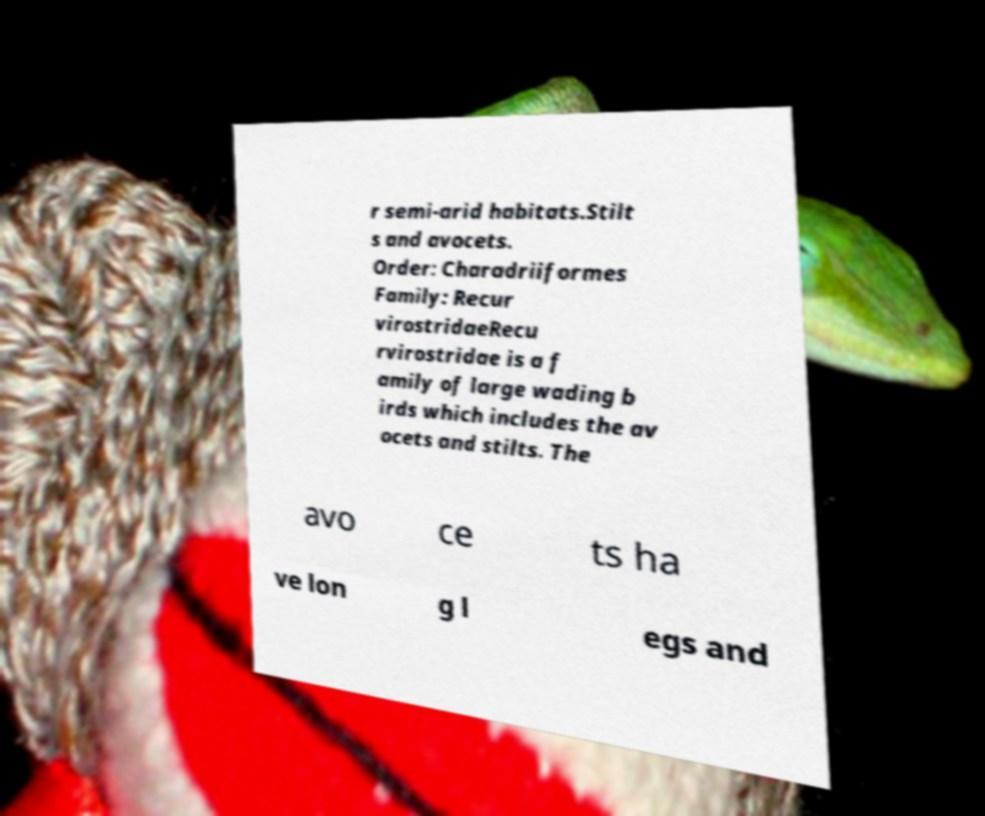There's text embedded in this image that I need extracted. Can you transcribe it verbatim? r semi-arid habitats.Stilt s and avocets. Order: Charadriiformes Family: Recur virostridaeRecu rvirostridae is a f amily of large wading b irds which includes the av ocets and stilts. The avo ce ts ha ve lon g l egs and 